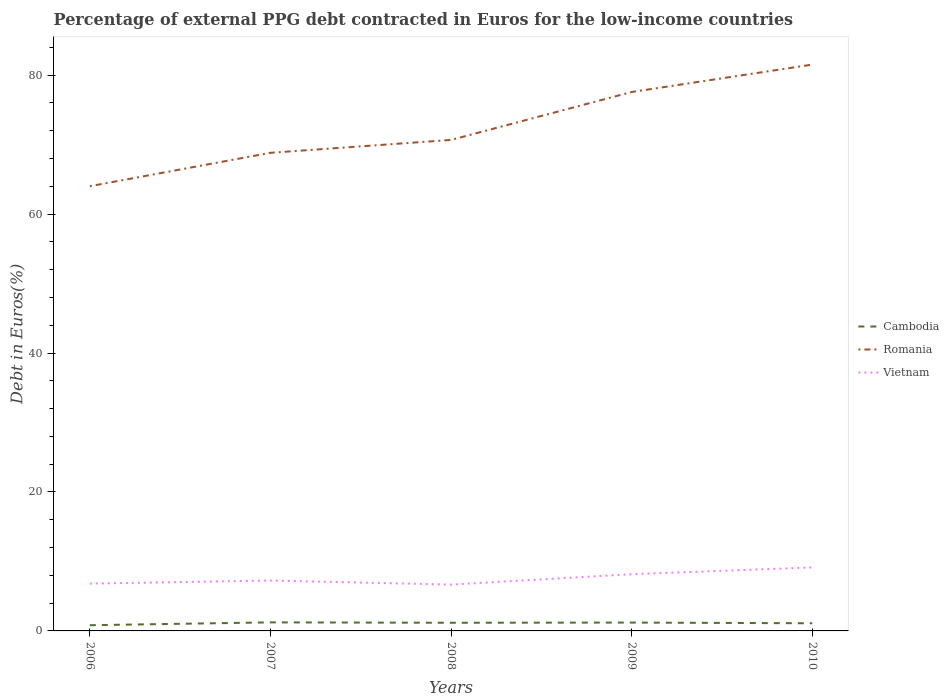Is the number of lines equal to the number of legend labels?
Your answer should be compact. Yes. Across all years, what is the maximum percentage of external PPG debt contracted in Euros in Romania?
Offer a terse response. 64.01. What is the total percentage of external PPG debt contracted in Euros in Vietnam in the graph?
Make the answer very short. -0.91. What is the difference between the highest and the second highest percentage of external PPG debt contracted in Euros in Romania?
Your answer should be compact. 17.5. How many lines are there?
Offer a very short reply. 3. How many years are there in the graph?
Ensure brevity in your answer.  5. What is the difference between two consecutive major ticks on the Y-axis?
Give a very brief answer. 20. Are the values on the major ticks of Y-axis written in scientific E-notation?
Provide a short and direct response. No. Does the graph contain any zero values?
Your answer should be compact. No. Does the graph contain grids?
Make the answer very short. No. What is the title of the graph?
Your answer should be compact. Percentage of external PPG debt contracted in Euros for the low-income countries. Does "Lesotho" appear as one of the legend labels in the graph?
Give a very brief answer. No. What is the label or title of the X-axis?
Your response must be concise. Years. What is the label or title of the Y-axis?
Provide a succinct answer. Debt in Euros(%). What is the Debt in Euros(%) in Cambodia in 2006?
Provide a succinct answer. 0.82. What is the Debt in Euros(%) of Romania in 2006?
Ensure brevity in your answer.  64.01. What is the Debt in Euros(%) in Vietnam in 2006?
Provide a succinct answer. 6.81. What is the Debt in Euros(%) in Cambodia in 2007?
Keep it short and to the point. 1.23. What is the Debt in Euros(%) in Romania in 2007?
Your response must be concise. 68.81. What is the Debt in Euros(%) of Vietnam in 2007?
Make the answer very short. 7.25. What is the Debt in Euros(%) in Cambodia in 2008?
Your response must be concise. 1.18. What is the Debt in Euros(%) in Romania in 2008?
Give a very brief answer. 70.67. What is the Debt in Euros(%) of Vietnam in 2008?
Your answer should be compact. 6.67. What is the Debt in Euros(%) in Cambodia in 2009?
Keep it short and to the point. 1.2. What is the Debt in Euros(%) in Romania in 2009?
Your answer should be very brief. 77.57. What is the Debt in Euros(%) in Vietnam in 2009?
Offer a very short reply. 8.17. What is the Debt in Euros(%) in Cambodia in 2010?
Your response must be concise. 1.1. What is the Debt in Euros(%) in Romania in 2010?
Your answer should be compact. 81.51. What is the Debt in Euros(%) in Vietnam in 2010?
Your answer should be very brief. 9.14. Across all years, what is the maximum Debt in Euros(%) of Cambodia?
Keep it short and to the point. 1.23. Across all years, what is the maximum Debt in Euros(%) in Romania?
Give a very brief answer. 81.51. Across all years, what is the maximum Debt in Euros(%) in Vietnam?
Give a very brief answer. 9.14. Across all years, what is the minimum Debt in Euros(%) in Cambodia?
Offer a very short reply. 0.82. Across all years, what is the minimum Debt in Euros(%) in Romania?
Offer a very short reply. 64.01. Across all years, what is the minimum Debt in Euros(%) of Vietnam?
Ensure brevity in your answer.  6.67. What is the total Debt in Euros(%) in Cambodia in the graph?
Offer a very short reply. 5.53. What is the total Debt in Euros(%) in Romania in the graph?
Provide a succinct answer. 362.56. What is the total Debt in Euros(%) of Vietnam in the graph?
Ensure brevity in your answer.  38.03. What is the difference between the Debt in Euros(%) in Cambodia in 2006 and that in 2007?
Your response must be concise. -0.41. What is the difference between the Debt in Euros(%) of Romania in 2006 and that in 2007?
Your response must be concise. -4.81. What is the difference between the Debt in Euros(%) of Vietnam in 2006 and that in 2007?
Your answer should be compact. -0.44. What is the difference between the Debt in Euros(%) in Cambodia in 2006 and that in 2008?
Offer a terse response. -0.35. What is the difference between the Debt in Euros(%) in Romania in 2006 and that in 2008?
Your response must be concise. -6.66. What is the difference between the Debt in Euros(%) in Vietnam in 2006 and that in 2008?
Offer a very short reply. 0.14. What is the difference between the Debt in Euros(%) of Cambodia in 2006 and that in 2009?
Ensure brevity in your answer.  -0.38. What is the difference between the Debt in Euros(%) of Romania in 2006 and that in 2009?
Ensure brevity in your answer.  -13.56. What is the difference between the Debt in Euros(%) of Vietnam in 2006 and that in 2009?
Give a very brief answer. -1.36. What is the difference between the Debt in Euros(%) of Cambodia in 2006 and that in 2010?
Your response must be concise. -0.28. What is the difference between the Debt in Euros(%) in Romania in 2006 and that in 2010?
Provide a succinct answer. -17.5. What is the difference between the Debt in Euros(%) in Vietnam in 2006 and that in 2010?
Your answer should be very brief. -2.33. What is the difference between the Debt in Euros(%) of Cambodia in 2007 and that in 2008?
Give a very brief answer. 0.05. What is the difference between the Debt in Euros(%) in Romania in 2007 and that in 2008?
Ensure brevity in your answer.  -1.86. What is the difference between the Debt in Euros(%) of Vietnam in 2007 and that in 2008?
Make the answer very short. 0.59. What is the difference between the Debt in Euros(%) of Cambodia in 2007 and that in 2009?
Provide a succinct answer. 0.03. What is the difference between the Debt in Euros(%) in Romania in 2007 and that in 2009?
Your answer should be very brief. -8.75. What is the difference between the Debt in Euros(%) in Vietnam in 2007 and that in 2009?
Your response must be concise. -0.91. What is the difference between the Debt in Euros(%) of Cambodia in 2007 and that in 2010?
Give a very brief answer. 0.13. What is the difference between the Debt in Euros(%) of Romania in 2007 and that in 2010?
Your answer should be compact. -12.7. What is the difference between the Debt in Euros(%) of Vietnam in 2007 and that in 2010?
Provide a short and direct response. -1.88. What is the difference between the Debt in Euros(%) in Cambodia in 2008 and that in 2009?
Keep it short and to the point. -0.03. What is the difference between the Debt in Euros(%) of Romania in 2008 and that in 2009?
Ensure brevity in your answer.  -6.9. What is the difference between the Debt in Euros(%) in Vietnam in 2008 and that in 2009?
Keep it short and to the point. -1.5. What is the difference between the Debt in Euros(%) of Cambodia in 2008 and that in 2010?
Keep it short and to the point. 0.07. What is the difference between the Debt in Euros(%) in Romania in 2008 and that in 2010?
Ensure brevity in your answer.  -10.84. What is the difference between the Debt in Euros(%) of Vietnam in 2008 and that in 2010?
Give a very brief answer. -2.47. What is the difference between the Debt in Euros(%) in Cambodia in 2009 and that in 2010?
Ensure brevity in your answer.  0.1. What is the difference between the Debt in Euros(%) in Romania in 2009 and that in 2010?
Your response must be concise. -3.94. What is the difference between the Debt in Euros(%) in Vietnam in 2009 and that in 2010?
Your answer should be very brief. -0.97. What is the difference between the Debt in Euros(%) in Cambodia in 2006 and the Debt in Euros(%) in Romania in 2007?
Provide a short and direct response. -67.99. What is the difference between the Debt in Euros(%) of Cambodia in 2006 and the Debt in Euros(%) of Vietnam in 2007?
Offer a terse response. -6.43. What is the difference between the Debt in Euros(%) of Romania in 2006 and the Debt in Euros(%) of Vietnam in 2007?
Your answer should be compact. 56.75. What is the difference between the Debt in Euros(%) in Cambodia in 2006 and the Debt in Euros(%) in Romania in 2008?
Your answer should be compact. -69.85. What is the difference between the Debt in Euros(%) in Cambodia in 2006 and the Debt in Euros(%) in Vietnam in 2008?
Provide a succinct answer. -5.84. What is the difference between the Debt in Euros(%) in Romania in 2006 and the Debt in Euros(%) in Vietnam in 2008?
Ensure brevity in your answer.  57.34. What is the difference between the Debt in Euros(%) in Cambodia in 2006 and the Debt in Euros(%) in Romania in 2009?
Ensure brevity in your answer.  -76.74. What is the difference between the Debt in Euros(%) of Cambodia in 2006 and the Debt in Euros(%) of Vietnam in 2009?
Keep it short and to the point. -7.34. What is the difference between the Debt in Euros(%) of Romania in 2006 and the Debt in Euros(%) of Vietnam in 2009?
Provide a succinct answer. 55.84. What is the difference between the Debt in Euros(%) in Cambodia in 2006 and the Debt in Euros(%) in Romania in 2010?
Keep it short and to the point. -80.69. What is the difference between the Debt in Euros(%) in Cambodia in 2006 and the Debt in Euros(%) in Vietnam in 2010?
Offer a very short reply. -8.32. What is the difference between the Debt in Euros(%) in Romania in 2006 and the Debt in Euros(%) in Vietnam in 2010?
Your answer should be compact. 54.87. What is the difference between the Debt in Euros(%) in Cambodia in 2007 and the Debt in Euros(%) in Romania in 2008?
Your answer should be very brief. -69.44. What is the difference between the Debt in Euros(%) in Cambodia in 2007 and the Debt in Euros(%) in Vietnam in 2008?
Your answer should be very brief. -5.44. What is the difference between the Debt in Euros(%) in Romania in 2007 and the Debt in Euros(%) in Vietnam in 2008?
Ensure brevity in your answer.  62.15. What is the difference between the Debt in Euros(%) of Cambodia in 2007 and the Debt in Euros(%) of Romania in 2009?
Offer a very short reply. -76.34. What is the difference between the Debt in Euros(%) in Cambodia in 2007 and the Debt in Euros(%) in Vietnam in 2009?
Offer a terse response. -6.94. What is the difference between the Debt in Euros(%) of Romania in 2007 and the Debt in Euros(%) of Vietnam in 2009?
Offer a very short reply. 60.65. What is the difference between the Debt in Euros(%) of Cambodia in 2007 and the Debt in Euros(%) of Romania in 2010?
Give a very brief answer. -80.28. What is the difference between the Debt in Euros(%) of Cambodia in 2007 and the Debt in Euros(%) of Vietnam in 2010?
Your response must be concise. -7.91. What is the difference between the Debt in Euros(%) in Romania in 2007 and the Debt in Euros(%) in Vietnam in 2010?
Your response must be concise. 59.68. What is the difference between the Debt in Euros(%) in Cambodia in 2008 and the Debt in Euros(%) in Romania in 2009?
Make the answer very short. -76.39. What is the difference between the Debt in Euros(%) of Cambodia in 2008 and the Debt in Euros(%) of Vietnam in 2009?
Provide a succinct answer. -6.99. What is the difference between the Debt in Euros(%) of Romania in 2008 and the Debt in Euros(%) of Vietnam in 2009?
Provide a short and direct response. 62.5. What is the difference between the Debt in Euros(%) of Cambodia in 2008 and the Debt in Euros(%) of Romania in 2010?
Provide a short and direct response. -80.33. What is the difference between the Debt in Euros(%) in Cambodia in 2008 and the Debt in Euros(%) in Vietnam in 2010?
Make the answer very short. -7.96. What is the difference between the Debt in Euros(%) in Romania in 2008 and the Debt in Euros(%) in Vietnam in 2010?
Offer a very short reply. 61.53. What is the difference between the Debt in Euros(%) of Cambodia in 2009 and the Debt in Euros(%) of Romania in 2010?
Provide a short and direct response. -80.31. What is the difference between the Debt in Euros(%) in Cambodia in 2009 and the Debt in Euros(%) in Vietnam in 2010?
Your answer should be compact. -7.93. What is the difference between the Debt in Euros(%) in Romania in 2009 and the Debt in Euros(%) in Vietnam in 2010?
Your answer should be compact. 68.43. What is the average Debt in Euros(%) in Cambodia per year?
Offer a terse response. 1.11. What is the average Debt in Euros(%) of Romania per year?
Provide a succinct answer. 72.51. What is the average Debt in Euros(%) of Vietnam per year?
Your answer should be very brief. 7.61. In the year 2006, what is the difference between the Debt in Euros(%) in Cambodia and Debt in Euros(%) in Romania?
Keep it short and to the point. -63.19. In the year 2006, what is the difference between the Debt in Euros(%) of Cambodia and Debt in Euros(%) of Vietnam?
Your response must be concise. -5.99. In the year 2006, what is the difference between the Debt in Euros(%) of Romania and Debt in Euros(%) of Vietnam?
Offer a very short reply. 57.2. In the year 2007, what is the difference between the Debt in Euros(%) in Cambodia and Debt in Euros(%) in Romania?
Offer a very short reply. -67.58. In the year 2007, what is the difference between the Debt in Euros(%) in Cambodia and Debt in Euros(%) in Vietnam?
Your answer should be compact. -6.02. In the year 2007, what is the difference between the Debt in Euros(%) of Romania and Debt in Euros(%) of Vietnam?
Keep it short and to the point. 61.56. In the year 2008, what is the difference between the Debt in Euros(%) of Cambodia and Debt in Euros(%) of Romania?
Provide a succinct answer. -69.49. In the year 2008, what is the difference between the Debt in Euros(%) of Cambodia and Debt in Euros(%) of Vietnam?
Keep it short and to the point. -5.49. In the year 2008, what is the difference between the Debt in Euros(%) of Romania and Debt in Euros(%) of Vietnam?
Your response must be concise. 64. In the year 2009, what is the difference between the Debt in Euros(%) of Cambodia and Debt in Euros(%) of Romania?
Provide a short and direct response. -76.36. In the year 2009, what is the difference between the Debt in Euros(%) of Cambodia and Debt in Euros(%) of Vietnam?
Offer a terse response. -6.96. In the year 2009, what is the difference between the Debt in Euros(%) of Romania and Debt in Euros(%) of Vietnam?
Offer a terse response. 69.4. In the year 2010, what is the difference between the Debt in Euros(%) in Cambodia and Debt in Euros(%) in Romania?
Provide a short and direct response. -80.41. In the year 2010, what is the difference between the Debt in Euros(%) in Cambodia and Debt in Euros(%) in Vietnam?
Your answer should be very brief. -8.04. In the year 2010, what is the difference between the Debt in Euros(%) of Romania and Debt in Euros(%) of Vietnam?
Your answer should be compact. 72.37. What is the ratio of the Debt in Euros(%) of Cambodia in 2006 to that in 2007?
Provide a short and direct response. 0.67. What is the ratio of the Debt in Euros(%) in Romania in 2006 to that in 2007?
Make the answer very short. 0.93. What is the ratio of the Debt in Euros(%) of Vietnam in 2006 to that in 2007?
Keep it short and to the point. 0.94. What is the ratio of the Debt in Euros(%) in Cambodia in 2006 to that in 2008?
Your answer should be very brief. 0.7. What is the ratio of the Debt in Euros(%) in Romania in 2006 to that in 2008?
Provide a short and direct response. 0.91. What is the ratio of the Debt in Euros(%) in Vietnam in 2006 to that in 2008?
Give a very brief answer. 1.02. What is the ratio of the Debt in Euros(%) in Cambodia in 2006 to that in 2009?
Offer a terse response. 0.68. What is the ratio of the Debt in Euros(%) of Romania in 2006 to that in 2009?
Give a very brief answer. 0.83. What is the ratio of the Debt in Euros(%) of Vietnam in 2006 to that in 2009?
Keep it short and to the point. 0.83. What is the ratio of the Debt in Euros(%) of Cambodia in 2006 to that in 2010?
Your response must be concise. 0.75. What is the ratio of the Debt in Euros(%) in Romania in 2006 to that in 2010?
Offer a terse response. 0.79. What is the ratio of the Debt in Euros(%) in Vietnam in 2006 to that in 2010?
Offer a terse response. 0.75. What is the ratio of the Debt in Euros(%) in Cambodia in 2007 to that in 2008?
Provide a short and direct response. 1.05. What is the ratio of the Debt in Euros(%) of Romania in 2007 to that in 2008?
Make the answer very short. 0.97. What is the ratio of the Debt in Euros(%) of Vietnam in 2007 to that in 2008?
Give a very brief answer. 1.09. What is the ratio of the Debt in Euros(%) in Cambodia in 2007 to that in 2009?
Make the answer very short. 1.02. What is the ratio of the Debt in Euros(%) of Romania in 2007 to that in 2009?
Give a very brief answer. 0.89. What is the ratio of the Debt in Euros(%) of Vietnam in 2007 to that in 2009?
Offer a very short reply. 0.89. What is the ratio of the Debt in Euros(%) in Cambodia in 2007 to that in 2010?
Ensure brevity in your answer.  1.12. What is the ratio of the Debt in Euros(%) in Romania in 2007 to that in 2010?
Your response must be concise. 0.84. What is the ratio of the Debt in Euros(%) of Vietnam in 2007 to that in 2010?
Ensure brevity in your answer.  0.79. What is the ratio of the Debt in Euros(%) in Cambodia in 2008 to that in 2009?
Ensure brevity in your answer.  0.98. What is the ratio of the Debt in Euros(%) in Romania in 2008 to that in 2009?
Ensure brevity in your answer.  0.91. What is the ratio of the Debt in Euros(%) in Vietnam in 2008 to that in 2009?
Provide a short and direct response. 0.82. What is the ratio of the Debt in Euros(%) of Cambodia in 2008 to that in 2010?
Give a very brief answer. 1.07. What is the ratio of the Debt in Euros(%) of Romania in 2008 to that in 2010?
Provide a succinct answer. 0.87. What is the ratio of the Debt in Euros(%) of Vietnam in 2008 to that in 2010?
Provide a succinct answer. 0.73. What is the ratio of the Debt in Euros(%) of Cambodia in 2009 to that in 2010?
Your answer should be very brief. 1.09. What is the ratio of the Debt in Euros(%) in Romania in 2009 to that in 2010?
Give a very brief answer. 0.95. What is the ratio of the Debt in Euros(%) in Vietnam in 2009 to that in 2010?
Your answer should be compact. 0.89. What is the difference between the highest and the second highest Debt in Euros(%) of Cambodia?
Your response must be concise. 0.03. What is the difference between the highest and the second highest Debt in Euros(%) in Romania?
Ensure brevity in your answer.  3.94. What is the difference between the highest and the second highest Debt in Euros(%) in Vietnam?
Give a very brief answer. 0.97. What is the difference between the highest and the lowest Debt in Euros(%) in Cambodia?
Keep it short and to the point. 0.41. What is the difference between the highest and the lowest Debt in Euros(%) of Romania?
Provide a short and direct response. 17.5. What is the difference between the highest and the lowest Debt in Euros(%) in Vietnam?
Your response must be concise. 2.47. 